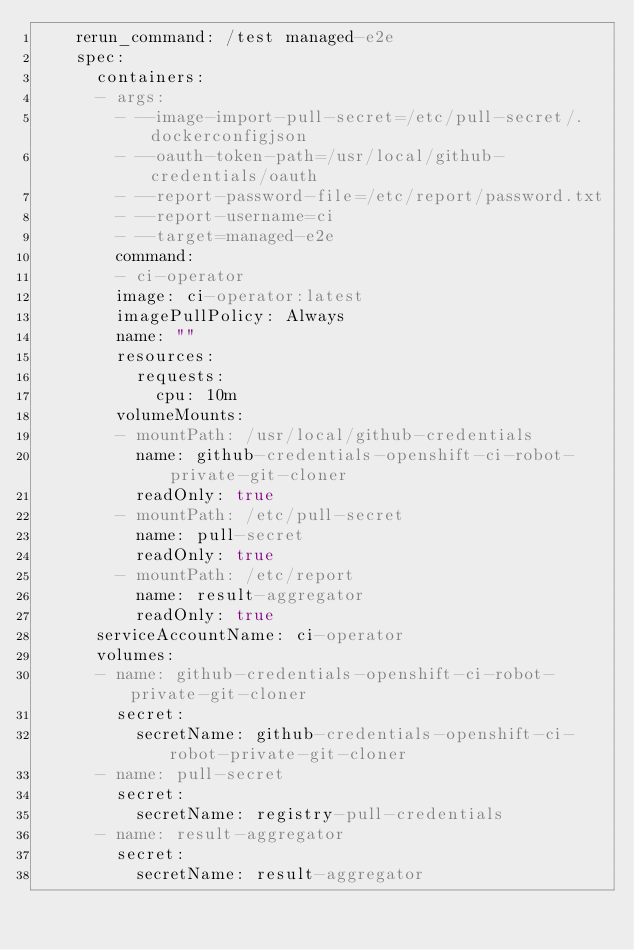Convert code to text. <code><loc_0><loc_0><loc_500><loc_500><_YAML_>    rerun_command: /test managed-e2e
    spec:
      containers:
      - args:
        - --image-import-pull-secret=/etc/pull-secret/.dockerconfigjson
        - --oauth-token-path=/usr/local/github-credentials/oauth
        - --report-password-file=/etc/report/password.txt
        - --report-username=ci
        - --target=managed-e2e
        command:
        - ci-operator
        image: ci-operator:latest
        imagePullPolicy: Always
        name: ""
        resources:
          requests:
            cpu: 10m
        volumeMounts:
        - mountPath: /usr/local/github-credentials
          name: github-credentials-openshift-ci-robot-private-git-cloner
          readOnly: true
        - mountPath: /etc/pull-secret
          name: pull-secret
          readOnly: true
        - mountPath: /etc/report
          name: result-aggregator
          readOnly: true
      serviceAccountName: ci-operator
      volumes:
      - name: github-credentials-openshift-ci-robot-private-git-cloner
        secret:
          secretName: github-credentials-openshift-ci-robot-private-git-cloner
      - name: pull-secret
        secret:
          secretName: registry-pull-credentials
      - name: result-aggregator
        secret:
          secretName: result-aggregator</code> 